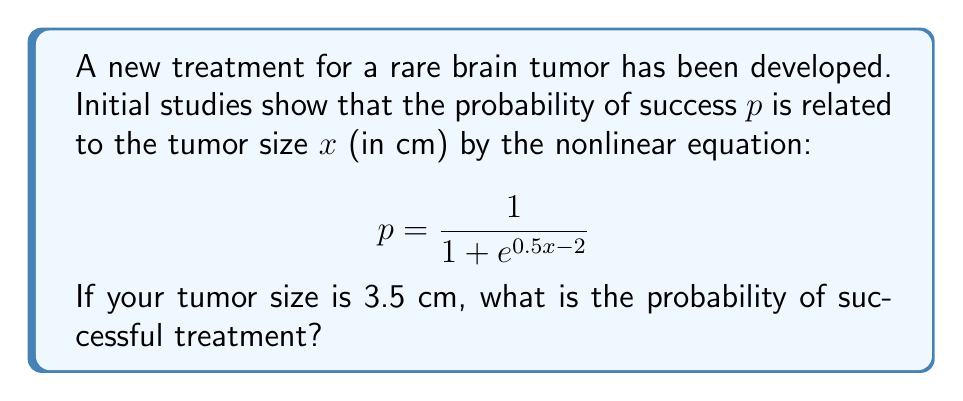Give your solution to this math problem. To solve this problem, we need to follow these steps:

1) We are given the nonlinear equation for the probability of success:

   $$p = \frac{1}{1 + e^{0.5x - 2}}$$

2) We know that the tumor size $x = 3.5$ cm. We need to substitute this value into the equation:

   $$p = \frac{1}{1 + e^{0.5(3.5) - 2}}$$

3) Let's simplify the exponent first:
   
   $0.5(3.5) - 2 = 1.75 - 2 = -0.25$

4) Now our equation looks like this:

   $$p = \frac{1}{1 + e^{-0.25}}$$

5) Calculate $e^{-0.25}$:
   
   $e^{-0.25} \approx 0.7788$

6) Substitute this value:

   $$p = \frac{1}{1 + 0.7788}$$

7) Simplify:

   $$p = \frac{1}{1.7788} \approx 0.5622$$

8) Convert to a percentage:

   $0.5622 * 100\% = 56.22\%$

Therefore, the probability of successful treatment is approximately 56.22%.
Answer: 56.22% 